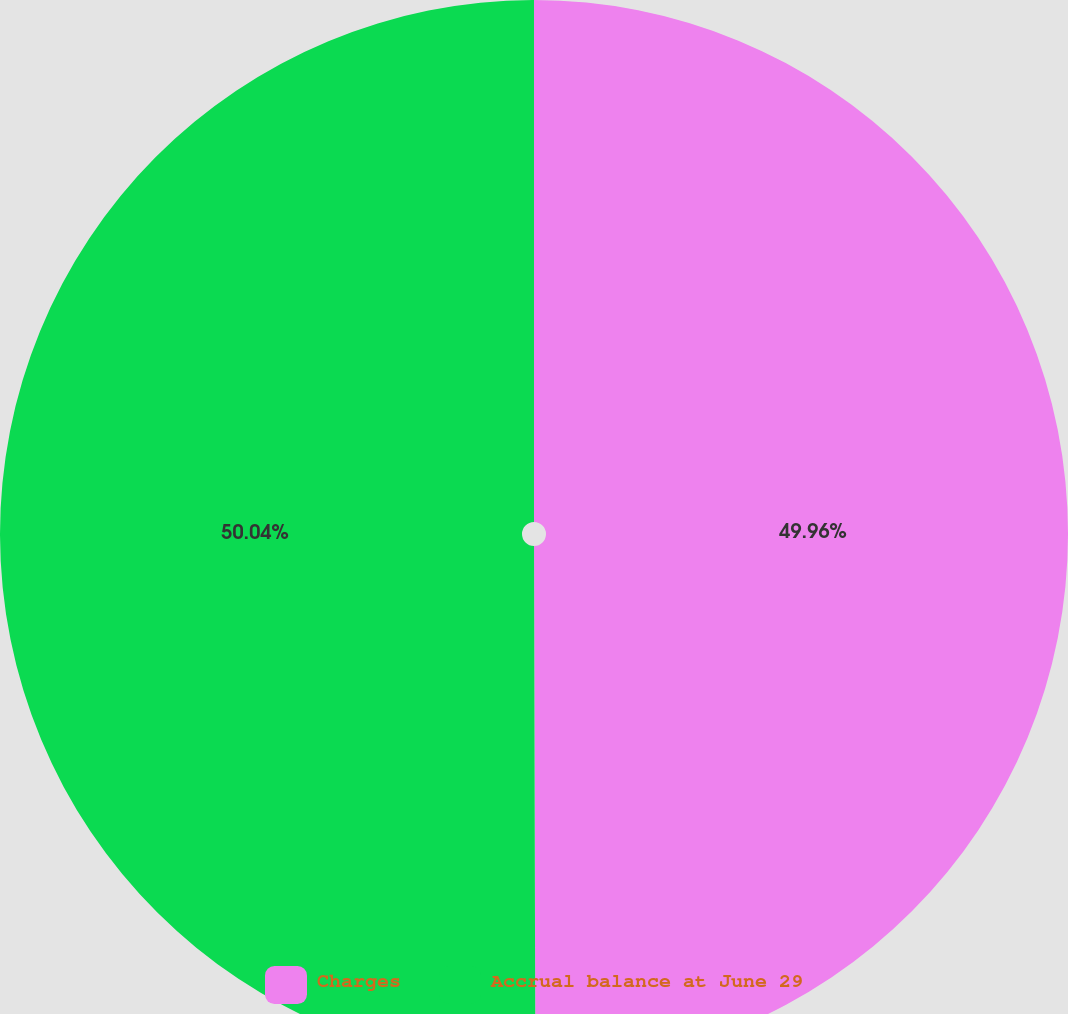Convert chart to OTSL. <chart><loc_0><loc_0><loc_500><loc_500><pie_chart><fcel>Charges<fcel>Accrual balance at June 29<nl><fcel>49.96%<fcel>50.04%<nl></chart> 